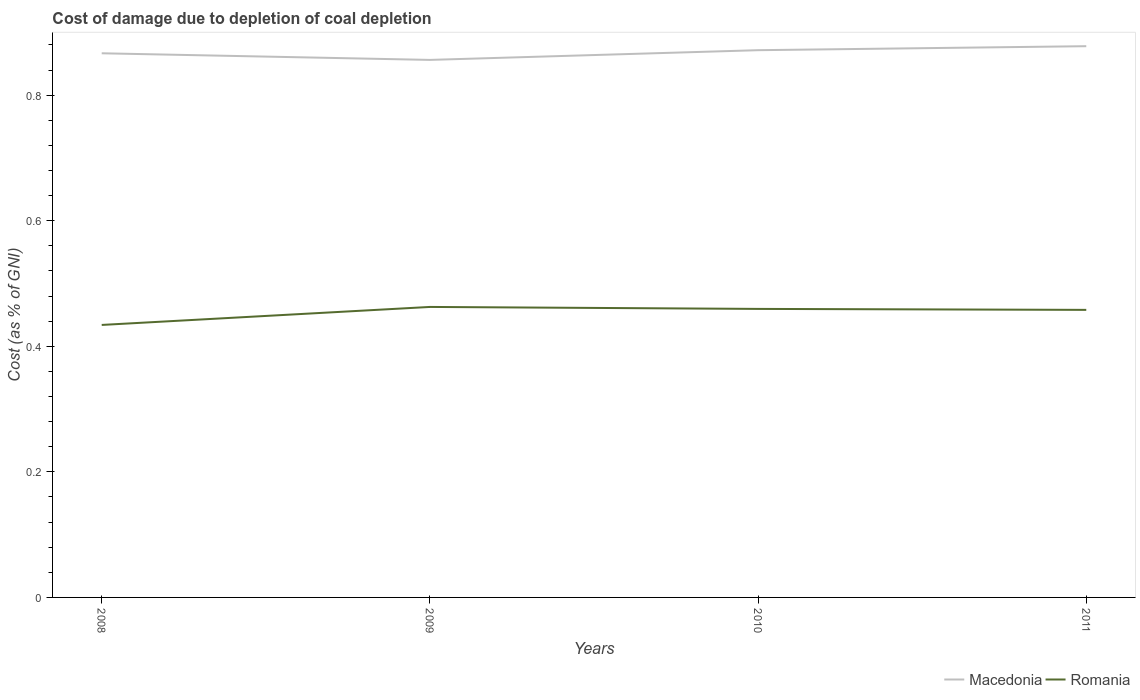Does the line corresponding to Romania intersect with the line corresponding to Macedonia?
Your response must be concise. No. Across all years, what is the maximum cost of damage caused due to coal depletion in Romania?
Ensure brevity in your answer.  0.43. In which year was the cost of damage caused due to coal depletion in Romania maximum?
Offer a terse response. 2008. What is the total cost of damage caused due to coal depletion in Romania in the graph?
Your answer should be very brief. -0.03. What is the difference between the highest and the second highest cost of damage caused due to coal depletion in Macedonia?
Provide a succinct answer. 0.02. Is the cost of damage caused due to coal depletion in Macedonia strictly greater than the cost of damage caused due to coal depletion in Romania over the years?
Your response must be concise. No. How many years are there in the graph?
Provide a succinct answer. 4. What is the difference between two consecutive major ticks on the Y-axis?
Offer a very short reply. 0.2. Does the graph contain grids?
Make the answer very short. No. Where does the legend appear in the graph?
Provide a succinct answer. Bottom right. What is the title of the graph?
Make the answer very short. Cost of damage due to depletion of coal depletion. Does "Peru" appear as one of the legend labels in the graph?
Keep it short and to the point. No. What is the label or title of the X-axis?
Your response must be concise. Years. What is the label or title of the Y-axis?
Ensure brevity in your answer.  Cost (as % of GNI). What is the Cost (as % of GNI) of Macedonia in 2008?
Give a very brief answer. 0.87. What is the Cost (as % of GNI) of Romania in 2008?
Provide a succinct answer. 0.43. What is the Cost (as % of GNI) in Macedonia in 2009?
Your answer should be very brief. 0.86. What is the Cost (as % of GNI) in Romania in 2009?
Keep it short and to the point. 0.46. What is the Cost (as % of GNI) of Macedonia in 2010?
Make the answer very short. 0.87. What is the Cost (as % of GNI) of Romania in 2010?
Provide a short and direct response. 0.46. What is the Cost (as % of GNI) of Macedonia in 2011?
Give a very brief answer. 0.88. What is the Cost (as % of GNI) of Romania in 2011?
Give a very brief answer. 0.46. Across all years, what is the maximum Cost (as % of GNI) in Macedonia?
Give a very brief answer. 0.88. Across all years, what is the maximum Cost (as % of GNI) of Romania?
Provide a short and direct response. 0.46. Across all years, what is the minimum Cost (as % of GNI) in Macedonia?
Keep it short and to the point. 0.86. Across all years, what is the minimum Cost (as % of GNI) in Romania?
Your response must be concise. 0.43. What is the total Cost (as % of GNI) of Macedonia in the graph?
Make the answer very short. 3.47. What is the total Cost (as % of GNI) in Romania in the graph?
Ensure brevity in your answer.  1.81. What is the difference between the Cost (as % of GNI) of Macedonia in 2008 and that in 2009?
Keep it short and to the point. 0.01. What is the difference between the Cost (as % of GNI) of Romania in 2008 and that in 2009?
Ensure brevity in your answer.  -0.03. What is the difference between the Cost (as % of GNI) of Macedonia in 2008 and that in 2010?
Your response must be concise. -0. What is the difference between the Cost (as % of GNI) of Romania in 2008 and that in 2010?
Ensure brevity in your answer.  -0.03. What is the difference between the Cost (as % of GNI) in Macedonia in 2008 and that in 2011?
Offer a terse response. -0.01. What is the difference between the Cost (as % of GNI) of Romania in 2008 and that in 2011?
Your response must be concise. -0.02. What is the difference between the Cost (as % of GNI) in Macedonia in 2009 and that in 2010?
Provide a succinct answer. -0.02. What is the difference between the Cost (as % of GNI) of Romania in 2009 and that in 2010?
Give a very brief answer. 0. What is the difference between the Cost (as % of GNI) in Macedonia in 2009 and that in 2011?
Give a very brief answer. -0.02. What is the difference between the Cost (as % of GNI) of Romania in 2009 and that in 2011?
Ensure brevity in your answer.  0. What is the difference between the Cost (as % of GNI) of Macedonia in 2010 and that in 2011?
Provide a succinct answer. -0.01. What is the difference between the Cost (as % of GNI) in Romania in 2010 and that in 2011?
Offer a very short reply. 0. What is the difference between the Cost (as % of GNI) in Macedonia in 2008 and the Cost (as % of GNI) in Romania in 2009?
Provide a succinct answer. 0.4. What is the difference between the Cost (as % of GNI) of Macedonia in 2008 and the Cost (as % of GNI) of Romania in 2010?
Offer a terse response. 0.41. What is the difference between the Cost (as % of GNI) in Macedonia in 2008 and the Cost (as % of GNI) in Romania in 2011?
Make the answer very short. 0.41. What is the difference between the Cost (as % of GNI) in Macedonia in 2009 and the Cost (as % of GNI) in Romania in 2010?
Your response must be concise. 0.4. What is the difference between the Cost (as % of GNI) of Macedonia in 2009 and the Cost (as % of GNI) of Romania in 2011?
Your response must be concise. 0.4. What is the difference between the Cost (as % of GNI) in Macedonia in 2010 and the Cost (as % of GNI) in Romania in 2011?
Your answer should be compact. 0.41. What is the average Cost (as % of GNI) in Macedonia per year?
Provide a succinct answer. 0.87. What is the average Cost (as % of GNI) in Romania per year?
Provide a short and direct response. 0.45. In the year 2008, what is the difference between the Cost (as % of GNI) of Macedonia and Cost (as % of GNI) of Romania?
Your answer should be compact. 0.43. In the year 2009, what is the difference between the Cost (as % of GNI) in Macedonia and Cost (as % of GNI) in Romania?
Provide a short and direct response. 0.39. In the year 2010, what is the difference between the Cost (as % of GNI) in Macedonia and Cost (as % of GNI) in Romania?
Make the answer very short. 0.41. In the year 2011, what is the difference between the Cost (as % of GNI) in Macedonia and Cost (as % of GNI) in Romania?
Keep it short and to the point. 0.42. What is the ratio of the Cost (as % of GNI) in Macedonia in 2008 to that in 2009?
Give a very brief answer. 1.01. What is the ratio of the Cost (as % of GNI) in Romania in 2008 to that in 2009?
Provide a short and direct response. 0.94. What is the ratio of the Cost (as % of GNI) of Romania in 2008 to that in 2010?
Make the answer very short. 0.94. What is the ratio of the Cost (as % of GNI) of Macedonia in 2008 to that in 2011?
Offer a terse response. 0.99. What is the ratio of the Cost (as % of GNI) in Romania in 2008 to that in 2011?
Ensure brevity in your answer.  0.95. What is the ratio of the Cost (as % of GNI) of Macedonia in 2009 to that in 2010?
Provide a short and direct response. 0.98. What is the ratio of the Cost (as % of GNI) of Romania in 2009 to that in 2010?
Your answer should be compact. 1.01. What is the ratio of the Cost (as % of GNI) of Macedonia in 2009 to that in 2011?
Offer a very short reply. 0.98. What is the ratio of the Cost (as % of GNI) of Romania in 2009 to that in 2011?
Ensure brevity in your answer.  1.01. What is the ratio of the Cost (as % of GNI) of Romania in 2010 to that in 2011?
Offer a very short reply. 1. What is the difference between the highest and the second highest Cost (as % of GNI) in Macedonia?
Ensure brevity in your answer.  0.01. What is the difference between the highest and the second highest Cost (as % of GNI) of Romania?
Your response must be concise. 0. What is the difference between the highest and the lowest Cost (as % of GNI) of Macedonia?
Offer a terse response. 0.02. What is the difference between the highest and the lowest Cost (as % of GNI) of Romania?
Ensure brevity in your answer.  0.03. 